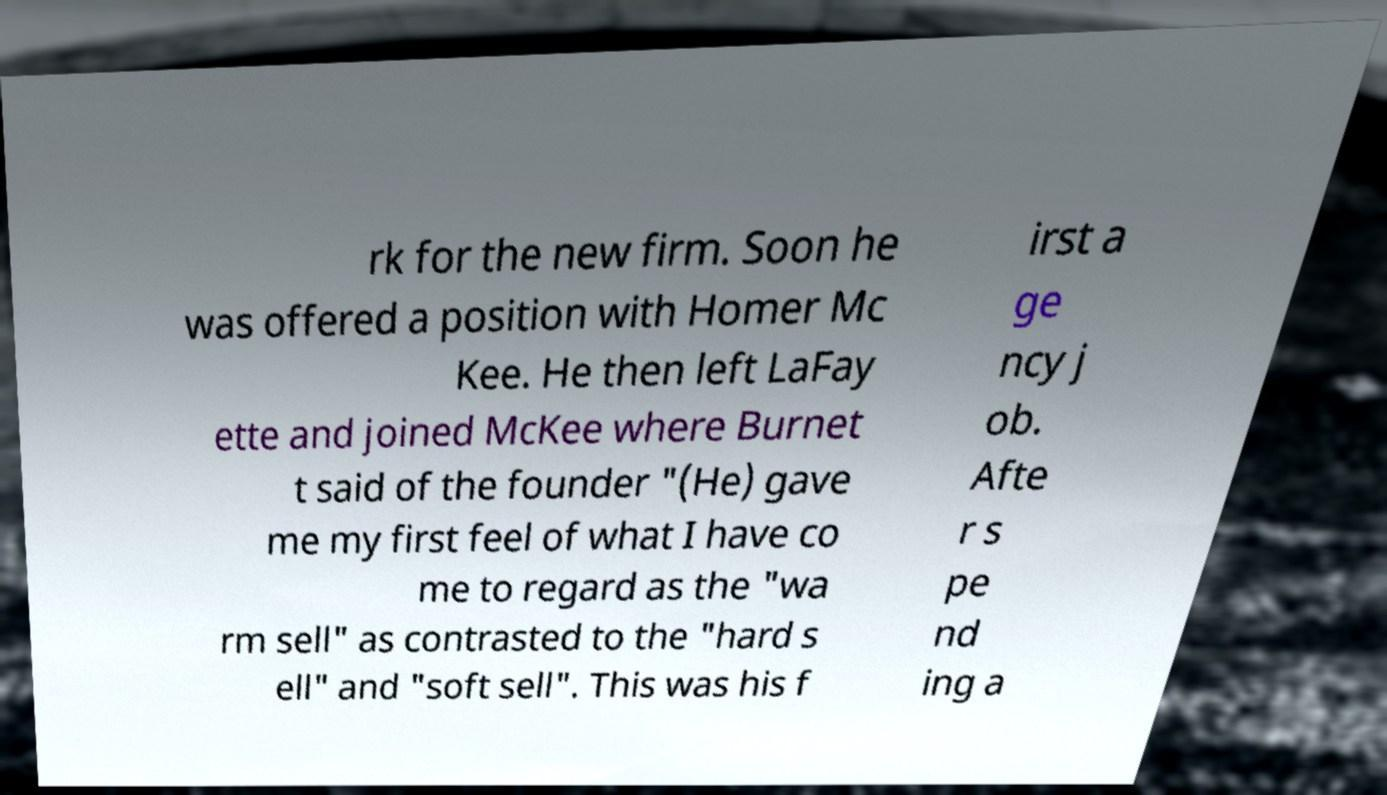Please read and relay the text visible in this image. What does it say? rk for the new firm. Soon he was offered a position with Homer Mc Kee. He then left LaFay ette and joined McKee where Burnet t said of the founder "(He) gave me my first feel of what I have co me to regard as the "wa rm sell" as contrasted to the "hard s ell" and "soft sell". This was his f irst a ge ncy j ob. Afte r s pe nd ing a 